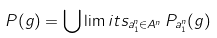<formula> <loc_0><loc_0><loc_500><loc_500>P ( g ) = \bigcup \lim i t s _ { a _ { 1 } ^ { n } \in A ^ { n } } \, P _ { a _ { 1 } ^ { n } } ( g )</formula> 